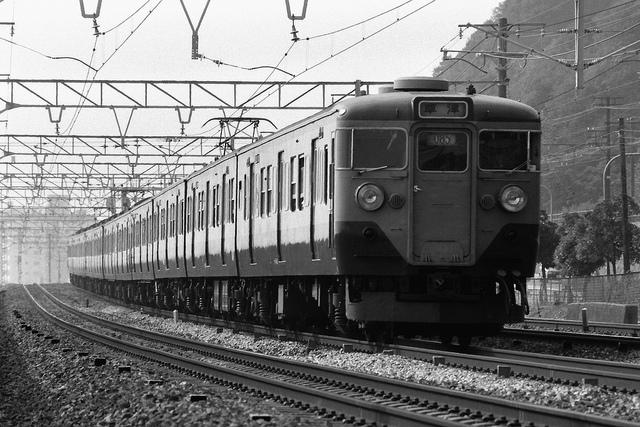Is this a freight train?
Quick response, please. No. Are the trains stopped?
Answer briefly. No. Is the train off the tracks?
Give a very brief answer. No. Is this a black and white photo?
Give a very brief answer. Yes. 